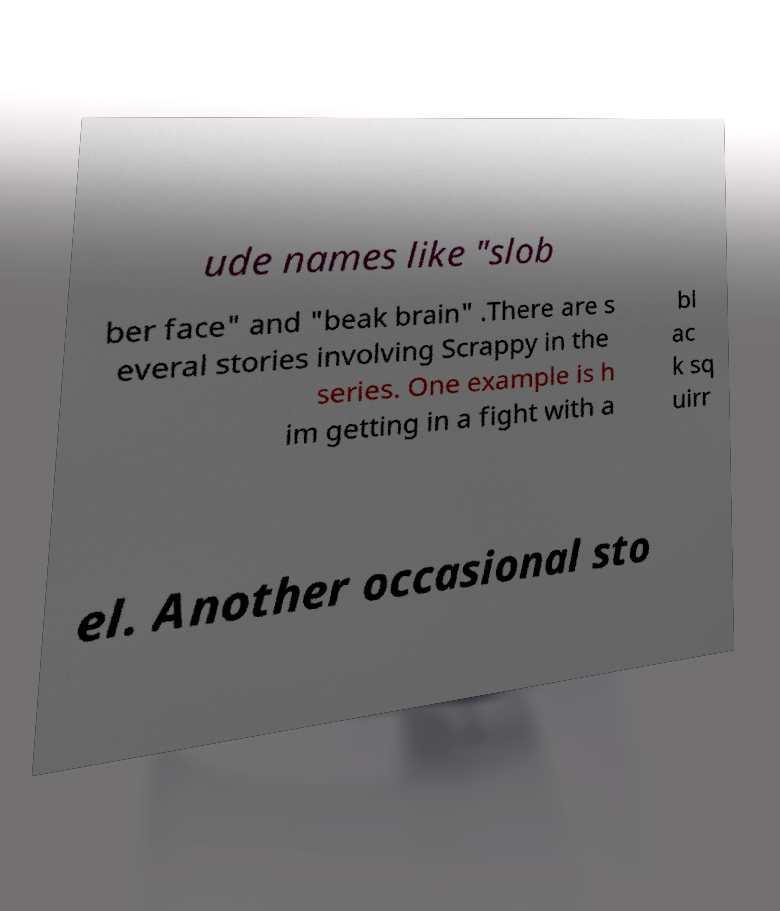Could you assist in decoding the text presented in this image and type it out clearly? ude names like "slob ber face" and "beak brain" .There are s everal stories involving Scrappy in the series. One example is h im getting in a fight with a bl ac k sq uirr el. Another occasional sto 